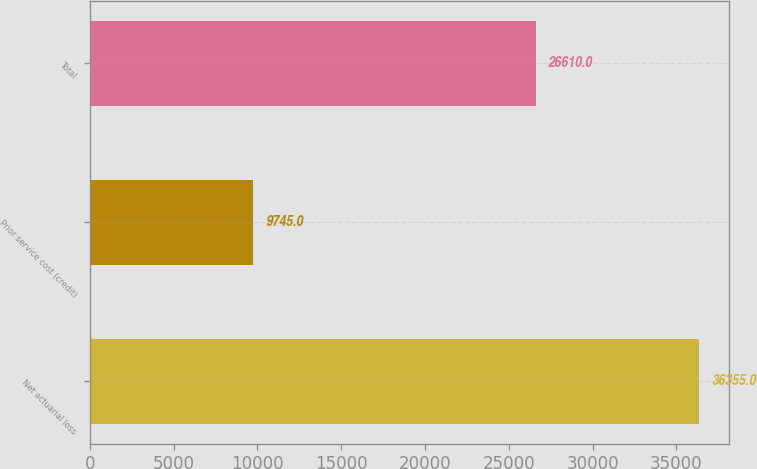Convert chart. <chart><loc_0><loc_0><loc_500><loc_500><bar_chart><fcel>Net actuarial loss<fcel>Prior service cost (credit)<fcel>Total<nl><fcel>36355<fcel>9745<fcel>26610<nl></chart> 